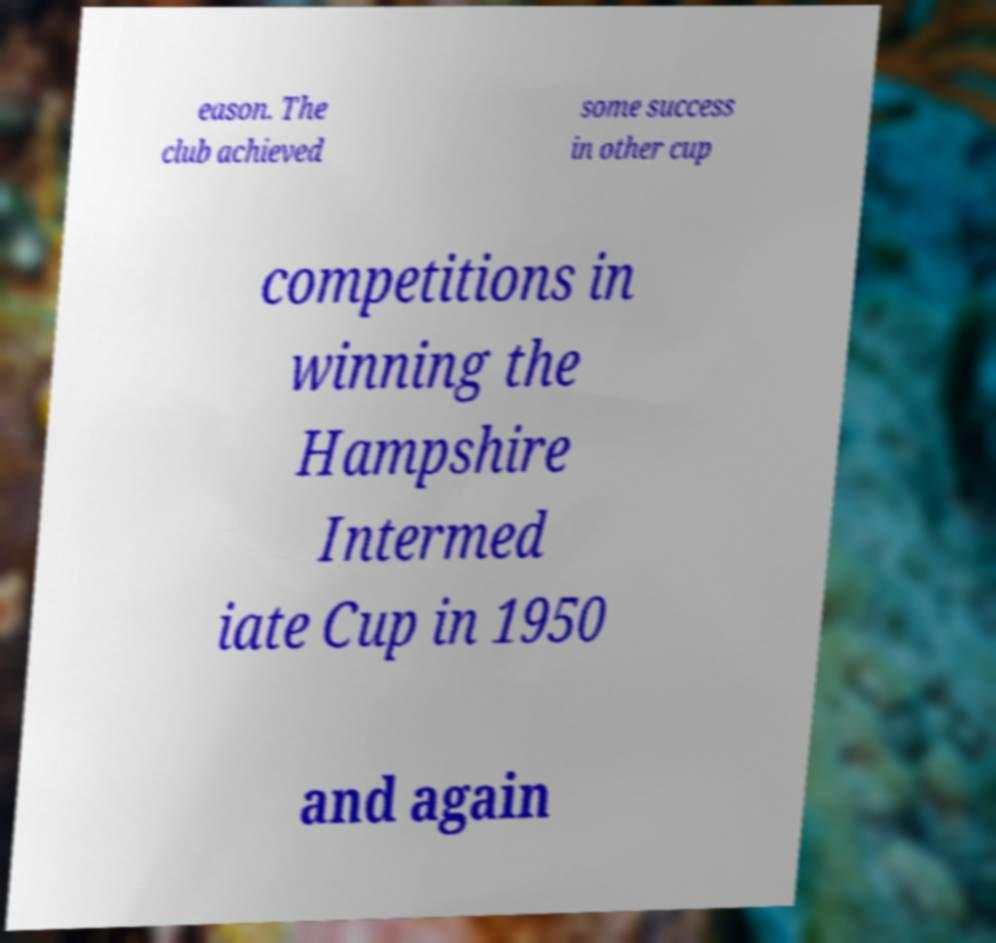Please read and relay the text visible in this image. What does it say? eason. The club achieved some success in other cup competitions in winning the Hampshire Intermed iate Cup in 1950 and again 